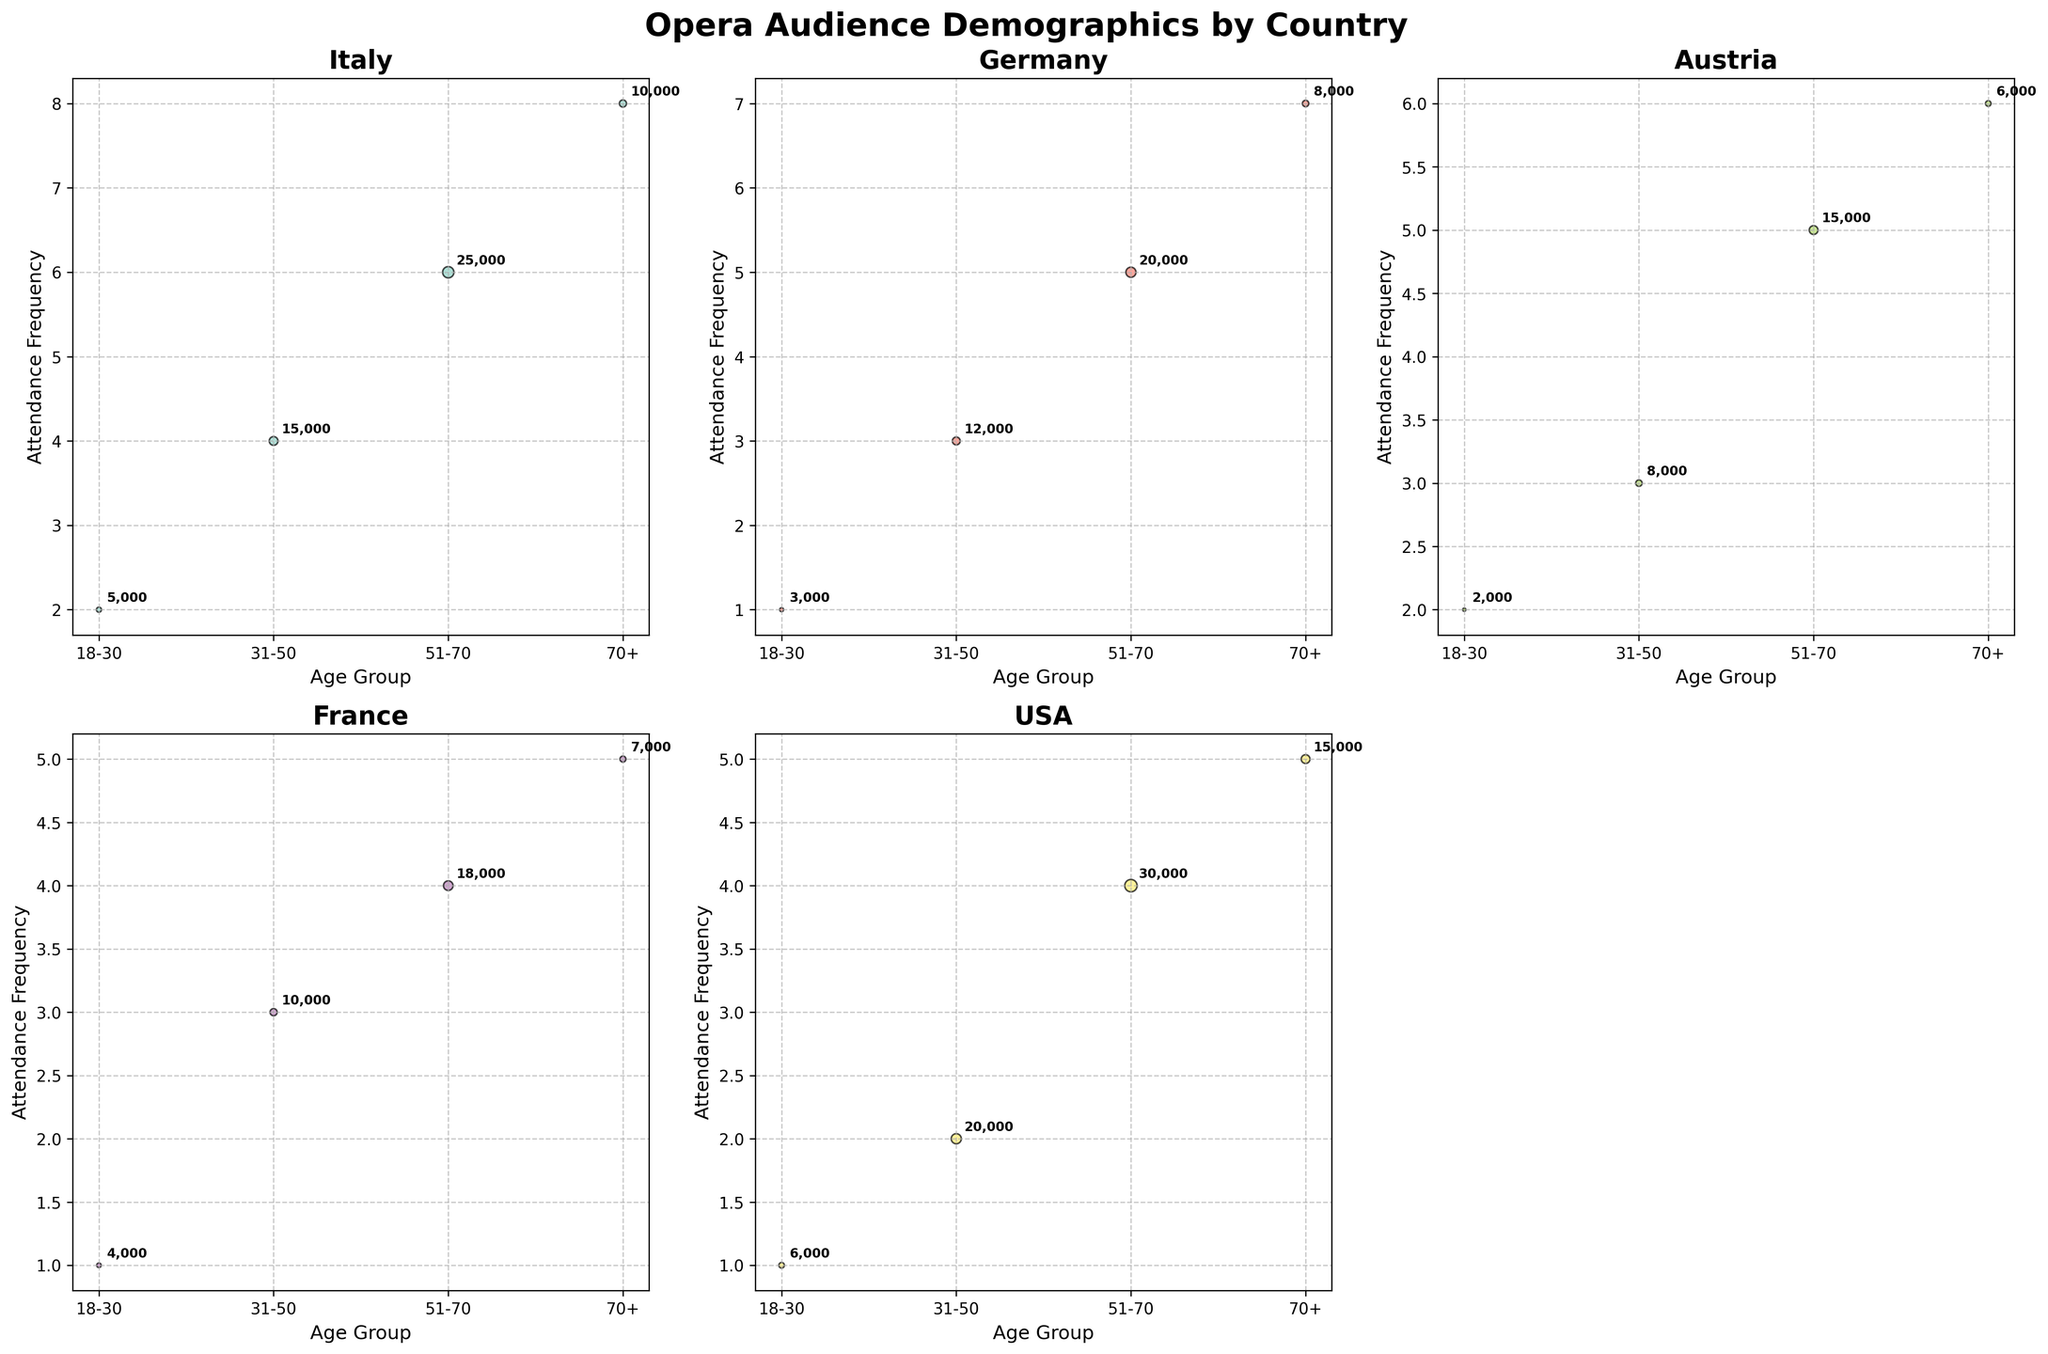What country's age group 51-70 has the highest attendance frequency? First, locate the 51-70 age group on each subplot. Then check the y-axis values for these age groups. The highest value for the age group 51-70 is 6, found in Italy.
Answer: Italy How many countries have an age group 70+ with an attendance frequency greater than 5? Identify the 70+ age groups in each subplot. Check which of these have an attendance frequency (y-axis) greater than 5. The countries are Italy, Germany, and the USA, which makes it a total of 3.
Answer: 3 In which country is the attendance frequency the lowest for the age group 18-30? Look at the 18-30 age groups in each subplot and note the y-axis values. Germany and France both have an attendance frequency of 1 for this age group. Choose any one of these two as the answer.
Answer: Germany or France Which country shows the most balanced attendance frequency across all age groups? Compare the attendance frequency ranges within each subplot. Germany has fairly uniform increments of 1 between the age groups, from 1 to 7. This indicates a balanced distribution.
Answer: Germany In Austria, which age group has the largest audience size? Examine the circle sizes in Austria's subplot. The largest circle corresponds to the age group 51-70, with an audience size of 15000.
Answer: 51-70 What is the sum of the audience sizes for the age group 31-50 across all countries? Add the audience sizes for the age group 31-50 in each subplot: 15000 (Italy) + 12000 (Germany) + 8000 (Austria) + 10000 (France) + 20000 (USA). The total is 15000+12000+8000+10000+20000=65000.
Answer: 65000 Which country has the smallest audience size for any age group and what is that size? Identify the smallest circles in each subplot, which represent the smallest audience sizes. Austria's 18-30 age group has the smallest audience size of 2000.
Answer: Austria, 2000 Does Germany or the USA have a larger audience for the age group 70+? Compare the circle sizes for the age group 70+ in Germany and the USA. Germany has 8000 and the USA has 15000 in this age group. The USA has a larger audience.
Answer: USA Which age group has the highest attendance frequency in France? Check the y-axis values in France's subplot to identify the highest attendance frequency, which is at the age group 70+ with a frequency of 5.
Answer: 70+ How does the audience size trend change with age in Italy? Examine the circle sizes in Italy's subplot and observe how they change with age groups. The sizes increase from 18-30 (5000) to 51-70 (25000) and then decrease to 70+ (10000).
Answer: Increases then decreases 